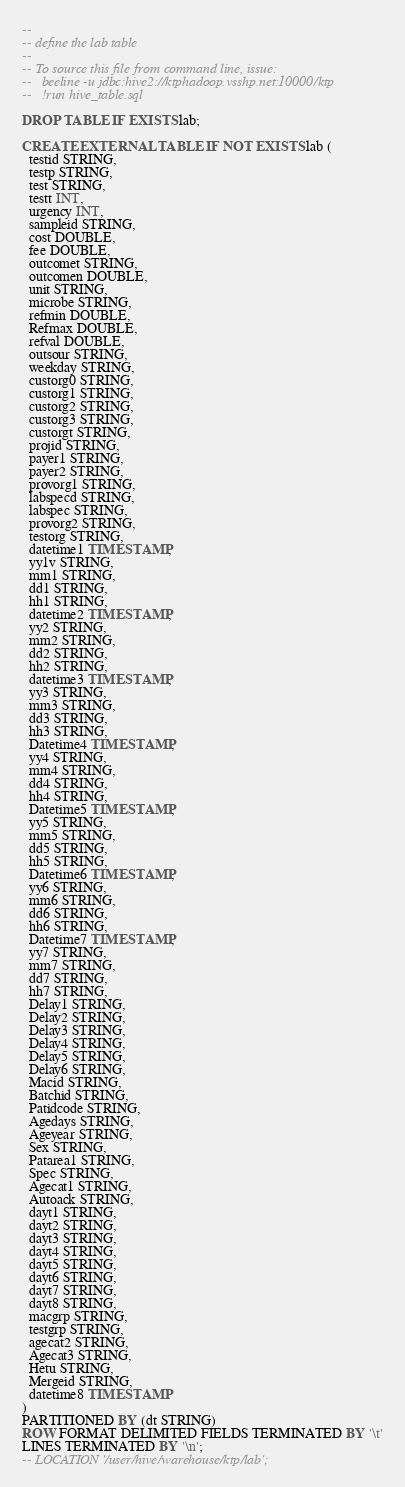<code> <loc_0><loc_0><loc_500><loc_500><_SQL_>--
-- define the lab table
-- 
-- To source this file from command line, issue:
--   beeline -u jdbc:hive2://ktphadoop.vsshp.net:10000/ktp
--   !run hive_table.sql

DROP TABLE IF EXISTS lab;

CREATE EXTERNAL TABLE IF NOT EXISTS lab (
  testid STRING,
  testp STRING,
  test STRING,
  testt INT,
  urgency INT,
  sampleid STRING,
  cost DOUBLE,
  fee DOUBLE,
  outcomet STRING,
  outcomen DOUBLE,
  unit STRING,
  microbe STRING,
  refmin DOUBLE,
  Refmax DOUBLE,
  refval DOUBLE,
  outsour STRING,
  weekday STRING,
  custorg0 STRING,
  custorg1 STRING,
  custorg2 STRING,
  custorg3 STRING,
  custorgt STRING,
  projid STRING,
  payer1 STRING,
  payer2 STRING,
  provorg1 STRING,
  labspecd STRING,
  labspec STRING,
  provorg2 STRING,
  testorg STRING,
  datetime1 TIMESTAMP,
  yy1v STRING,
  mm1 STRING,
  dd1 STRING,
  hh1 STRING,
  datetime2 TIMESTAMP,
  yy2 STRING,
  mm2 STRING,
  dd2 STRING,
  hh2 STRING,
  datetime3 TIMESTAMP,
  yy3 STRING,
  mm3 STRING,
  dd3 STRING,
  hh3 STRING,
  Datetime4 TIMESTAMP,
  yy4 STRING,
  mm4 STRING,
  dd4 STRING,
  hh4 STRING,
  Datetime5 TIMESTAMP,
  yy5 STRING,
  mm5 STRING,
  dd5 STRING,
  hh5 STRING,
  Datetime6 TIMESTAMP,
  yy6 STRING,
  mm6 STRING,
  dd6 STRING,
  hh6 STRING,
  Datetime7 TIMESTAMP,
  yy7 STRING,
  mm7 STRING,
  dd7 STRING,
  hh7 STRING,
  Delay1 STRING,
  Delay2 STRING,
  Delay3 STRING,
  Delay4 STRING,
  Delay5 STRING,
  Delay6 STRING,
  Macid STRING,
  Batchid STRING,
  Patidcode STRING,
  Agedays STRING,
  Ageyear STRING,
  Sex STRING,
  Patarea1 STRING,
  Spec STRING,
  Agecat1 STRING,
  Autoack STRING,
  dayt1 STRING,
  dayt2 STRING,
  dayt3 STRING,
  dayt4 STRING,
  dayt5 STRING,
  dayt6 STRING,
  dayt7 STRING,
  dayt8 STRING,
  macgrp STRING,
  testgrp STRING,
  agecat2 STRING,
  Agecat3 STRING,
  Hetu STRING,
  Mergeid STRING,
  datetime8 TIMESTAMP
)
PARTITIONED BY (dt STRING)
ROW FORMAT DELIMITED FIELDS TERMINATED BY '\t'
LINES TERMINATED BY '\n';
-- LOCATION '/user/hive/warehouse/ktp/lab';
</code> 